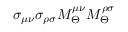Convert formula to latex. <formula><loc_0><loc_0><loc_500><loc_500>\sigma _ { \mu \nu } \sigma _ { \rho \sigma } M _ { \Theta } ^ { \mu \nu } M _ { \Theta } ^ { \rho \sigma }</formula> 